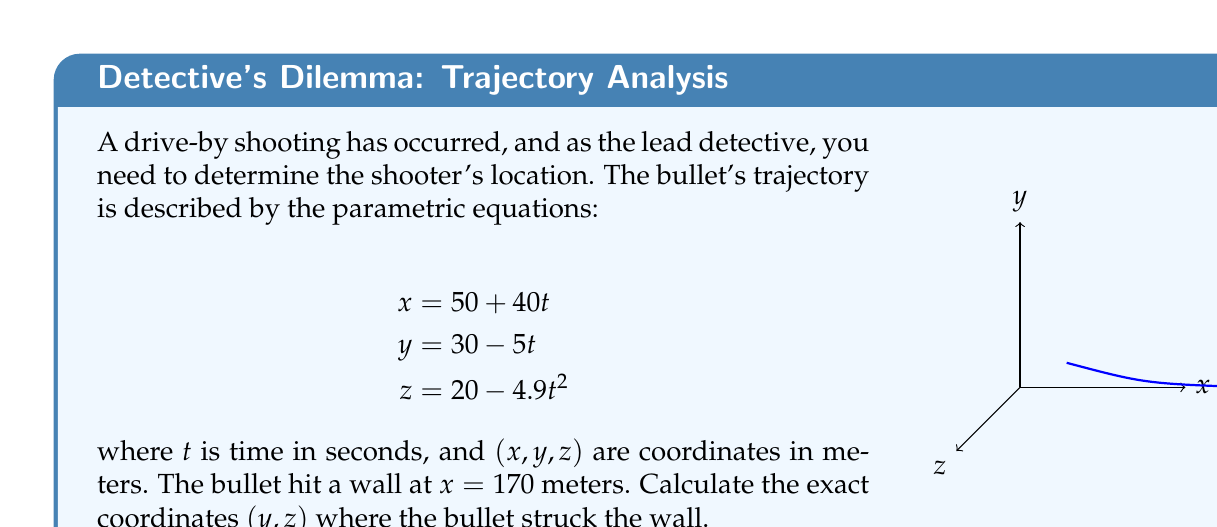What is the answer to this math problem? Let's approach this step-by-step:

1) We know that the bullet hit the wall at $x = 170$ meters. We can use this information to find the time $t$ when the bullet hit the wall:

   $$170 = 50 + 40t$$
   $$120 = 40t$$
   $$t = 3$$

2) Now that we know $t = 3$ seconds, we can substitute this value into the equations for $y$ and $z$:

   For $y$:
   $$y = 30 - 5t$$
   $$y = 30 - 5(3)$$
   $$y = 30 - 15 = 15$$

   For $z$:
   $$z = 20 - 4.9t^2$$
   $$z = 20 - 4.9(3^2)$$
   $$z = 20 - 4.9(9)$$
   $$z = 20 - 44.1 = -24.1$$

3) Therefore, the bullet hit the wall at the point $(170, 15, -24.1)$.
Answer: $(170, 15, -24.1)$ 